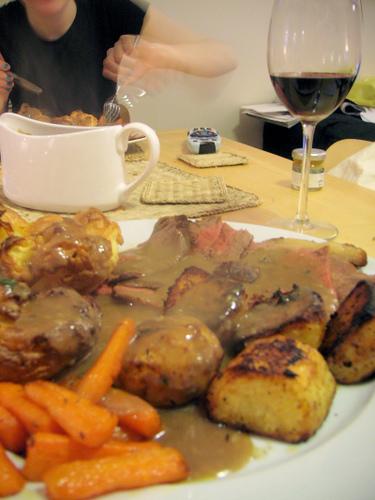Has the chicken been carved?
Answer briefly. Yes. Is this meal at a fancy restaurant?
Answer briefly. No. Is this healthy food?
Write a very short answer. No. Is this drink ice cold?
Give a very brief answer. No. 